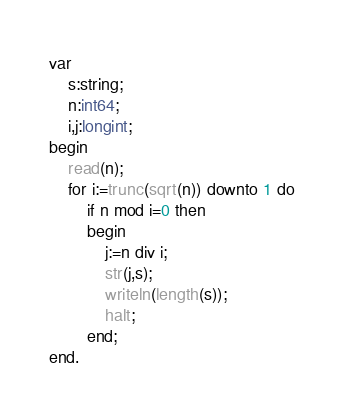Convert code to text. <code><loc_0><loc_0><loc_500><loc_500><_Pascal_>var
    s:string;
    n:int64;
    i,j:longint;
begin
    read(n);
    for i:=trunc(sqrt(n)) downto 1 do
        if n mod i=0 then
        begin
            j:=n div i;
            str(j,s);
            writeln(length(s));
            halt;
        end;
end.</code> 